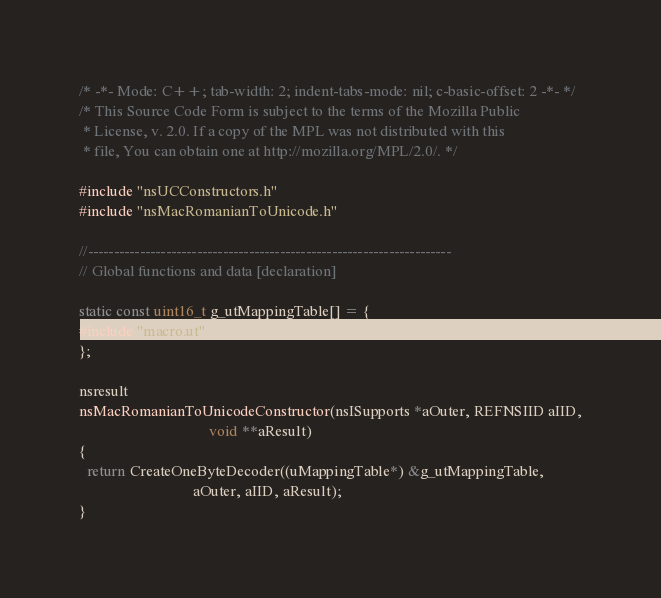Convert code to text. <code><loc_0><loc_0><loc_500><loc_500><_C++_>/* -*- Mode: C++; tab-width: 2; indent-tabs-mode: nil; c-basic-offset: 2 -*- */
/* This Source Code Form is subject to the terms of the Mozilla Public
 * License, v. 2.0. If a copy of the MPL was not distributed with this
 * file, You can obtain one at http://mozilla.org/MPL/2.0/. */

#include "nsUCConstructors.h"
#include "nsMacRomanianToUnicode.h"

//----------------------------------------------------------------------
// Global functions and data [declaration]

static const uint16_t g_utMappingTable[] = {
#include "macro.ut"
};

nsresult
nsMacRomanianToUnicodeConstructor(nsISupports *aOuter, REFNSIID aIID,
                                  void **aResult) 
{
  return CreateOneByteDecoder((uMappingTable*) &g_utMappingTable,
                              aOuter, aIID, aResult);
}
</code> 